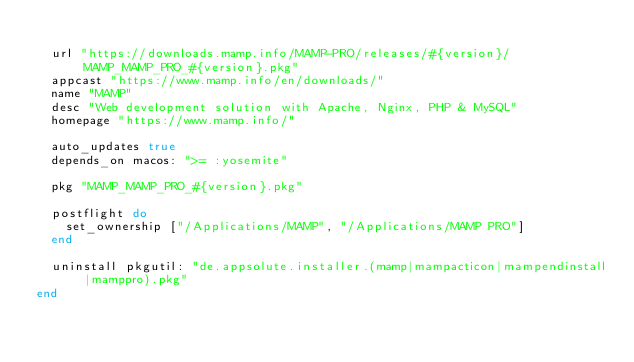Convert code to text. <code><loc_0><loc_0><loc_500><loc_500><_Ruby_>
  url "https://downloads.mamp.info/MAMP-PRO/releases/#{version}/MAMP_MAMP_PRO_#{version}.pkg"
  appcast "https://www.mamp.info/en/downloads/"
  name "MAMP"
  desc "Web development solution with Apache, Nginx, PHP & MySQL"
  homepage "https://www.mamp.info/"

  auto_updates true
  depends_on macos: ">= :yosemite"

  pkg "MAMP_MAMP_PRO_#{version}.pkg"

  postflight do
    set_ownership ["/Applications/MAMP", "/Applications/MAMP PRO"]
  end

  uninstall pkgutil: "de.appsolute.installer.(mamp|mampacticon|mampendinstall|mamppro).pkg"
end
</code> 